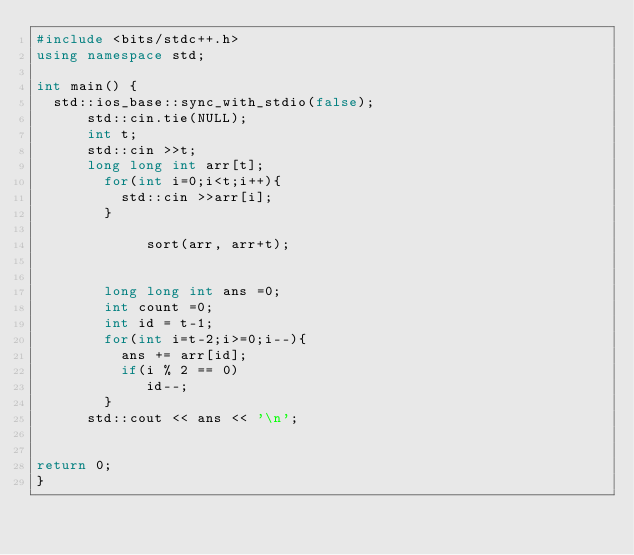<code> <loc_0><loc_0><loc_500><loc_500><_C++_>#include <bits/stdc++.h>
using namespace std;

int main() {
  std::ios_base::sync_with_stdio(false);
      std::cin.tie(NULL);
      int t;
      std::cin >>t;
      long long int arr[t];
        for(int i=0;i<t;i++){
          std::cin >>arr[i];
        }

             sort(arr, arr+t);


        long long int ans =0;
        int count =0;
        int id = t-1;
        for(int i=t-2;i>=0;i--){
          ans += arr[id];
          if(i % 2 == 0)
             id--;
        }
      std::cout << ans << '\n';


return 0;
}
</code> 